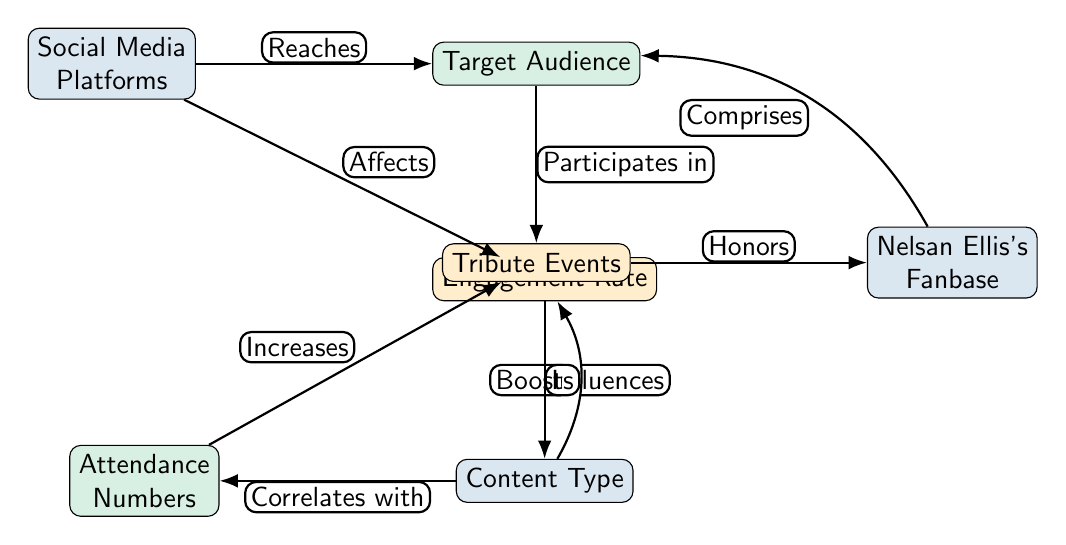What are the main components of the diagram? The diagram consists of seven main components: Social Media Platforms, Target Audience, Engagement Rate, Content Type, Attendance Numbers, Tribute Events, and Nelsan Ellis's Fanbase. These nodes are interconnected with directed edges indicating relationships among them.
Answer: Seven main components Which node is directly affected by the Engagement Rate? The Engagement Rate node directly influences the Content Type node according to the directed edge labeled "Influences." This indicates that changes in engagement rates can lead to variations in the types of content shared or created.
Answer: Content Type What relationship exists between Social Media Platforms and Target Audience? Social Media Platforms reach the Target Audience, as indicated by the directed edge labeled "Reaches." This demonstrates that social media platforms serve as a means to connect and deliver content to the specific audience that is engaged with Nelsan Ellis's tribute events.
Answer: Reaches How many edges are in the diagram? The diagram contains eight directed edges, each representing a relationship or flow between nodes. Counting these edges provides insights into the connections and influences among the components, which are vital for understanding the social media impact on event attendance.
Answer: Eight edges Which node boosts the Engagement Rate? The Content Type node boosts the Engagement Rate, as shown by the directed edge that describes this relationship. This suggests that the type of content shared through social media plays a significant role in increasing how engaged the audience becomes.
Answer: Content Type What is the correlation between Content Type and Attendance Numbers? Content Type correlates with Attendance Numbers, according to the directed edge labeled "Correlates with." This indicates that different types of content shared on social media can lead to varying levels of attendance at the tribute events.
Answer: Correlates with Which node honors Nelsan Ellis's Fanbase? The Tribute Events node honors Nelsan Ellis's Fanbase, as indicated by the edge labeled "Honors." This relationship emphasizes that the purpose of these events is to pay tribute to the legacy and work of Nelsan Ellis, directly engaging his fan community.
Answer: Tribute Events What effect does Attendance Numbers have on Tribute Events? Attendance Numbers increase the Tribute Events, as indicated by the edge labeled "Increases." This shows that a rise in the number of attendees can lead to an increase in the frequency or scale of events held to celebrate Nelsan Ellis's contributions.
Answer: Increases 